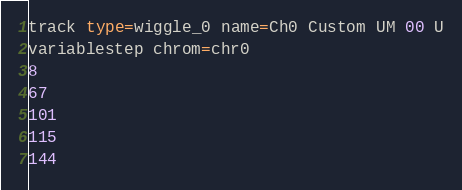Convert code to text. <code><loc_0><loc_0><loc_500><loc_500><_SQL_>track type=wiggle_0 name=Ch0 Custom UM 00 U
variablestep chrom=chr0
8
67
101
115
144
</code> 